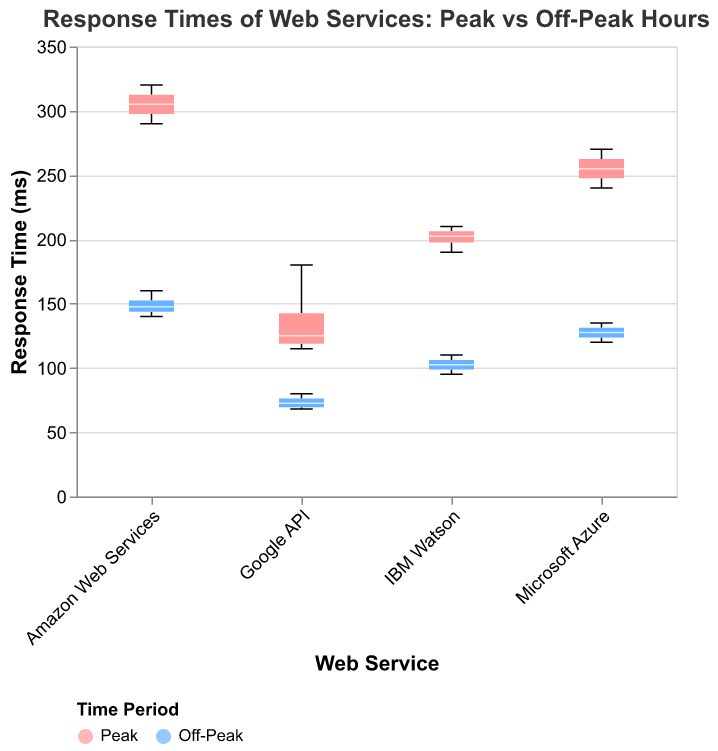What is the title of the plot? The title is located at the top of the plot and it reads 'Response Times of Web Services: Peak vs Off-Peak Hours'
Answer: Response Times of Web Services: Peak vs Off-Peak Hours What are the names of the web services displayed on the x-axis? The x-axis shows the labels for the different web services used in the study. These include 'Google API', 'Amazon Web Services', 'Microsoft Azure', and 'IBM Watson'
Answer: Google API, Amazon Web Services, Microsoft Azure, IBM Watson What is the range of response times for IBM Watson during off-peak hours? The range can be observed from the boxplot for IBM Watson during off-peak hours. It spans from the minimum to the maximum value within the boxplot's whiskers for off-peak hours. The times range from 95 ms to 110 ms
Answer: 95 ms to 110 ms What color represents the response times during peak hours? The color coding for the time periods is indicated in the legend. Peak hours are represented by a red color
Answer: Red Which web service has the highest median response time during peak hours? The median is marked by a white line inside each boxplot. By comparing the medians, Amazon Web Services has the highest median during peak hours. It is located highest along the y-axis among all peak hour boxes
Answer: Amazon Web Services How do the median response times of Microsoft Azure differ between peak and off-peak hours? By observing the white median lines inside the boxes for Microsoft Azure, the peak hour median is at 255 ms, while the off-peak hour median is at 127.5 ms. The difference can be calculated as 255 ms - 127.5 ms
Answer: 127.5 ms Compare the interquartile range (IQR) for Google API between peak and off-peak hours. The IQR is the range between the first quartile (bottom of the box) and the third quartile (top of the box). For Google API, during peak hours, the IQR spans from 115 ms to 130 ms, giving an IQR of 15 ms. During off-peak hours, it spans from 70 ms to 75 ms, giving an IQR of 5 ms
Answer: 15 ms (Peak) and 5 ms (Off-Peak) Which web service shows the smallest range for off-peak hours? The range is determined by the distance between the minimum and maximum whiskers in the boxplot. By observing all off-peak hour boxplots, Google API shows the smallest range, from 68 ms to 80 ms, making a total of 12 ms
Answer: Google API What is the overall trend in response times when comparing peak to off-peak hours across all services? The trend can be deduced by comparing the heights of the boxes for all services. In all cases, the boxplots for off-peak hours are lower than their corresponding peak hour boxplots, indicating lower response times during off-peak hours
Answer: Lower response times during off-peak hours Is there any service that does not have outliers for both peak and off-peak hours? Outliers are indicated by points outside the whiskers of the boxplots. Looking at all boxplots, IBM Watson does not have any outliers for either peak or off-peak hours
Answer: IBM Watson 